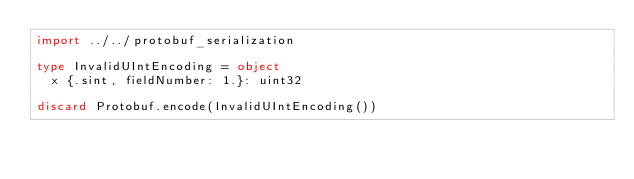<code> <loc_0><loc_0><loc_500><loc_500><_Nim_>import ../../protobuf_serialization

type InvalidUIntEncoding = object
  x {.sint, fieldNumber: 1.}: uint32

discard Protobuf.encode(InvalidUIntEncoding())
</code> 